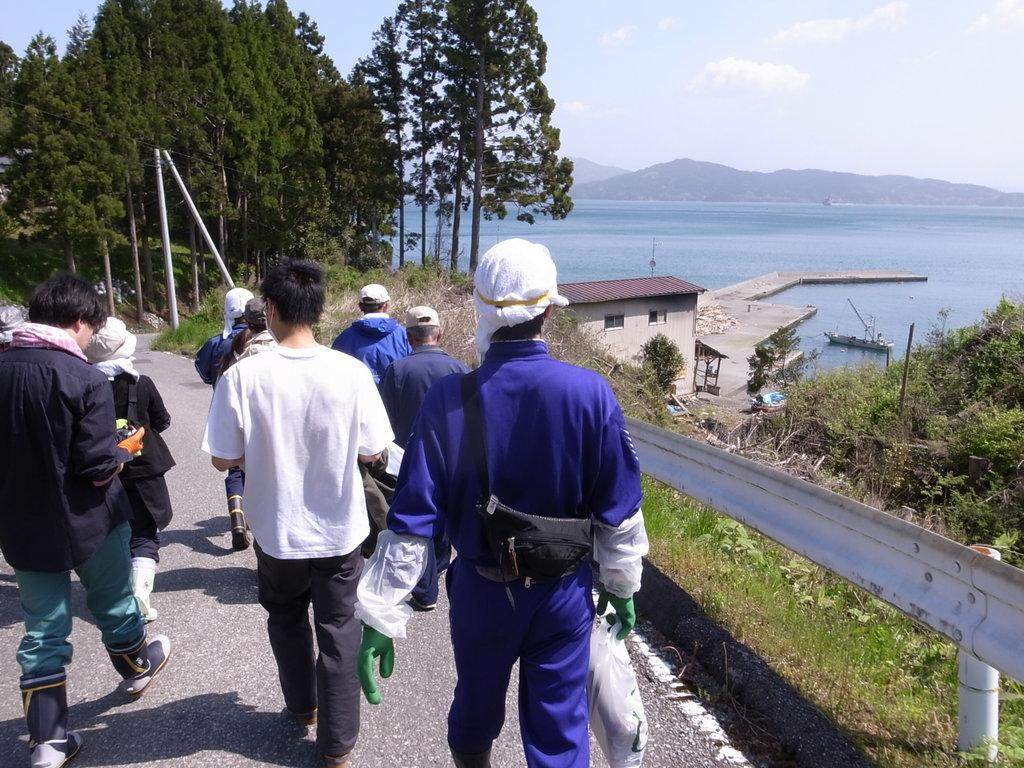What are the people in the image doing? The people in the image are walking on the road. What structure can be seen in the image? There is a walkway bridge in the image. What type of structures can be seen in the image? There are buildings in the image. What type of vehicle is present in the image? There is a ship in the image. What type of vertical structures are present in the image? There are poles in the image. What type of vegetation is present in the image? There are plants and grass in the image. What type of water body is present in the image? There is a river in the image. What type of landscape feature is present in the image? There are hills in the image. What type of tall vegetation is present in the image? There are trees in the image. What can be seen above the ground in the image? The sky is visible in the image. What type of atmospheric phenomena can be seen in the sky? There are clouds in the sky. What type of suit is the person wearing in the image? There is no person wearing a suit in the image. What type of statement can be seen written on the bridge in the image? There is no statement written on the bridge in the image. What type of eyes can be seen on the trees in the image? There are no eyes present on the trees in the image. 